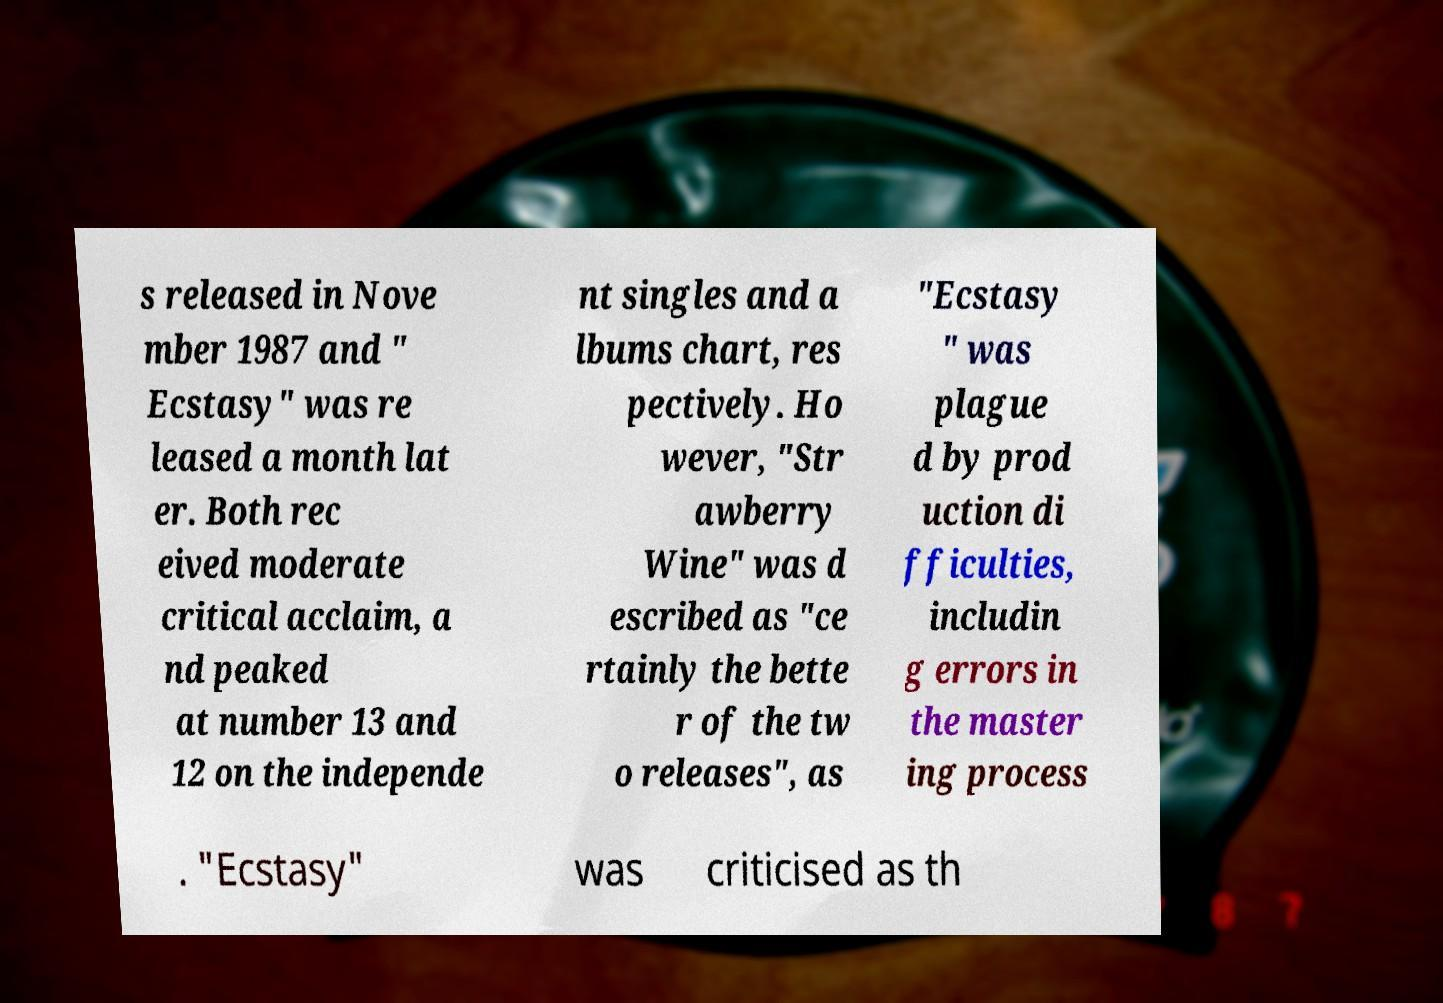Can you accurately transcribe the text from the provided image for me? s released in Nove mber 1987 and " Ecstasy" was re leased a month lat er. Both rec eived moderate critical acclaim, a nd peaked at number 13 and 12 on the independe nt singles and a lbums chart, res pectively. Ho wever, "Str awberry Wine" was d escribed as "ce rtainly the bette r of the tw o releases", as "Ecstasy " was plague d by prod uction di fficulties, includin g errors in the master ing process . "Ecstasy" was criticised as th 